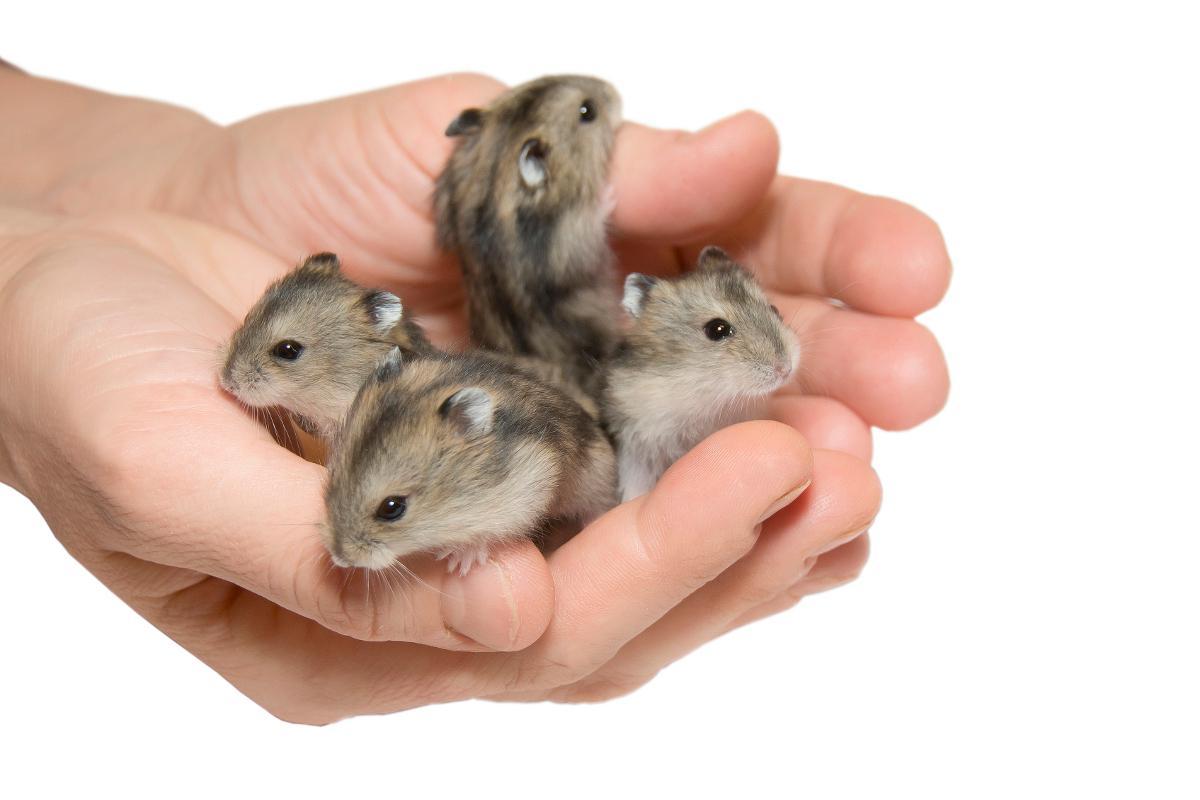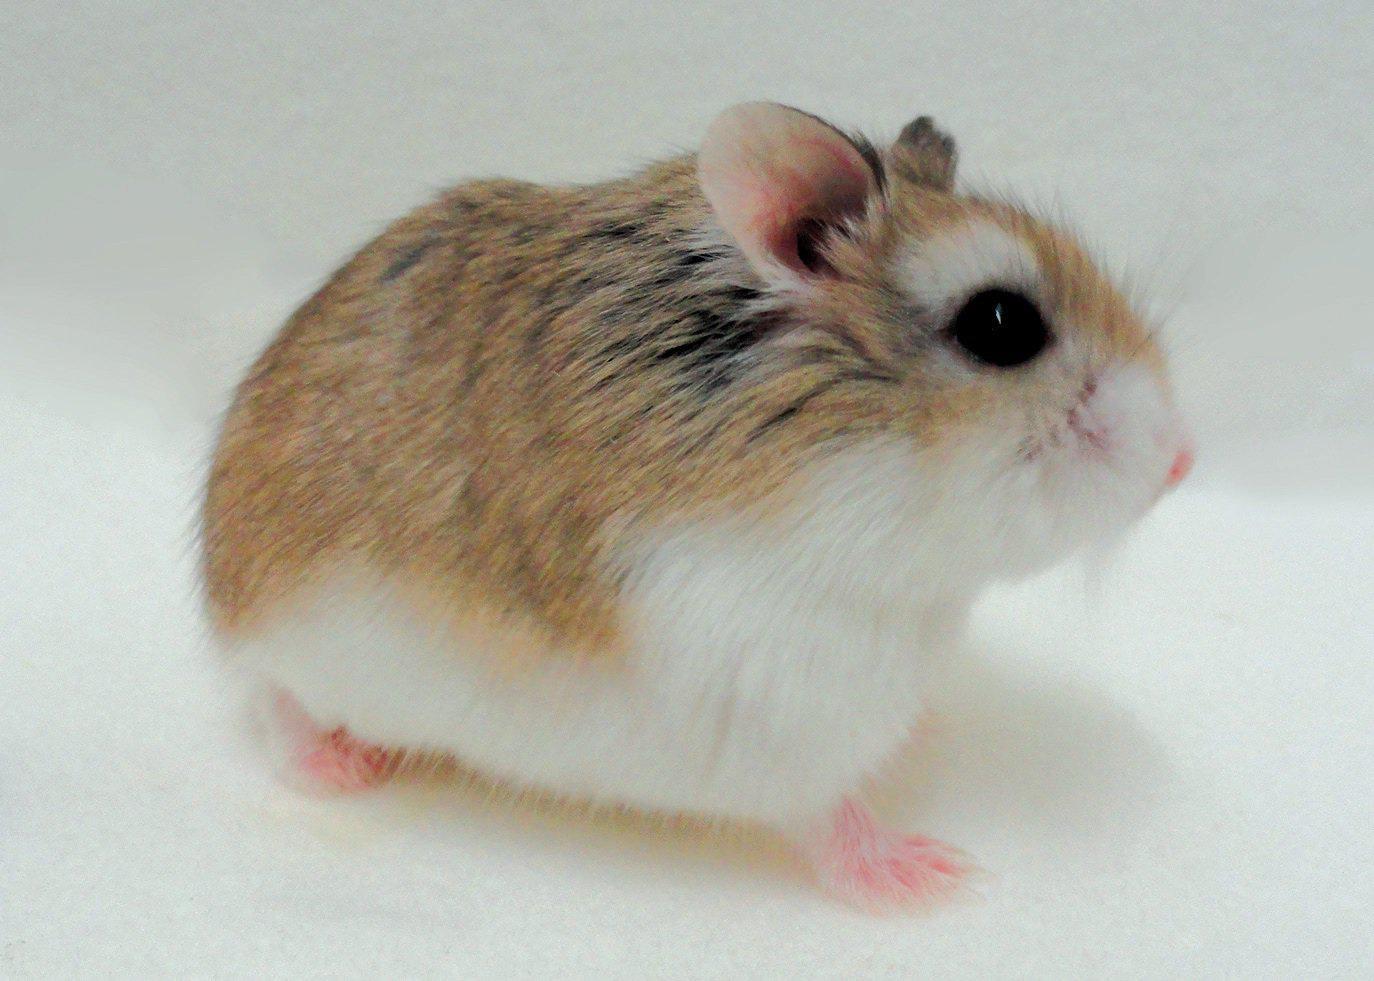The first image is the image on the left, the second image is the image on the right. Assess this claim about the two images: "One image shows at least one pet rodent on shredded bedding material, and the other image shows a hand holding no more than two pet rodents.". Correct or not? Answer yes or no. No. The first image is the image on the left, the second image is the image on the right. For the images shown, is this caption "There are at least five animals in total." true? Answer yes or no. Yes. 